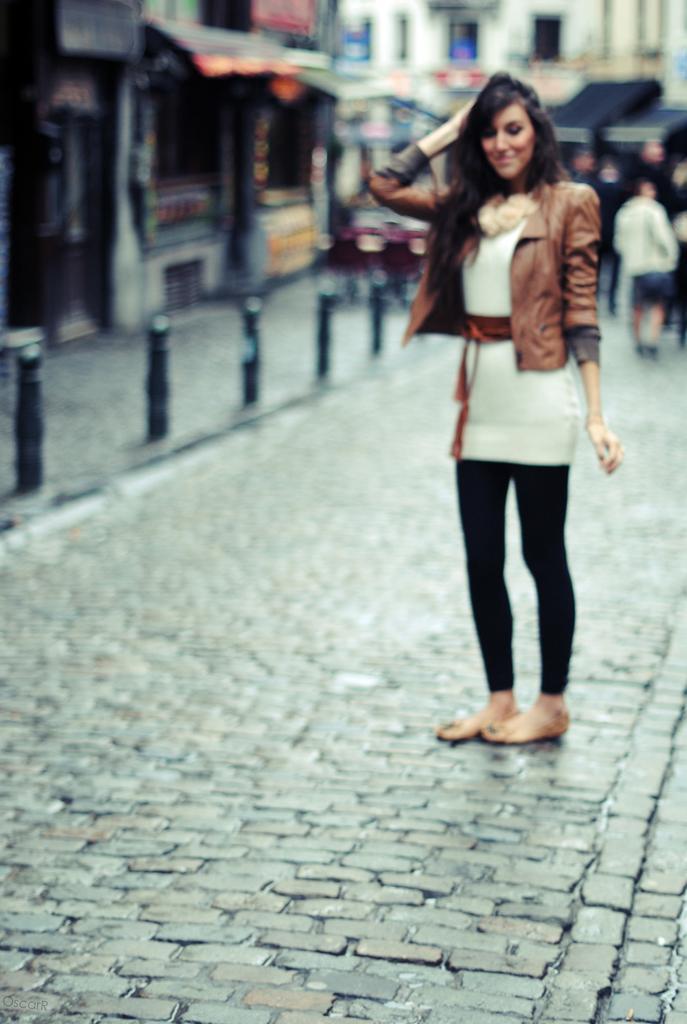Please provide a concise description of this image. There is a woman standing on surface. Background we can see buildings and person. 